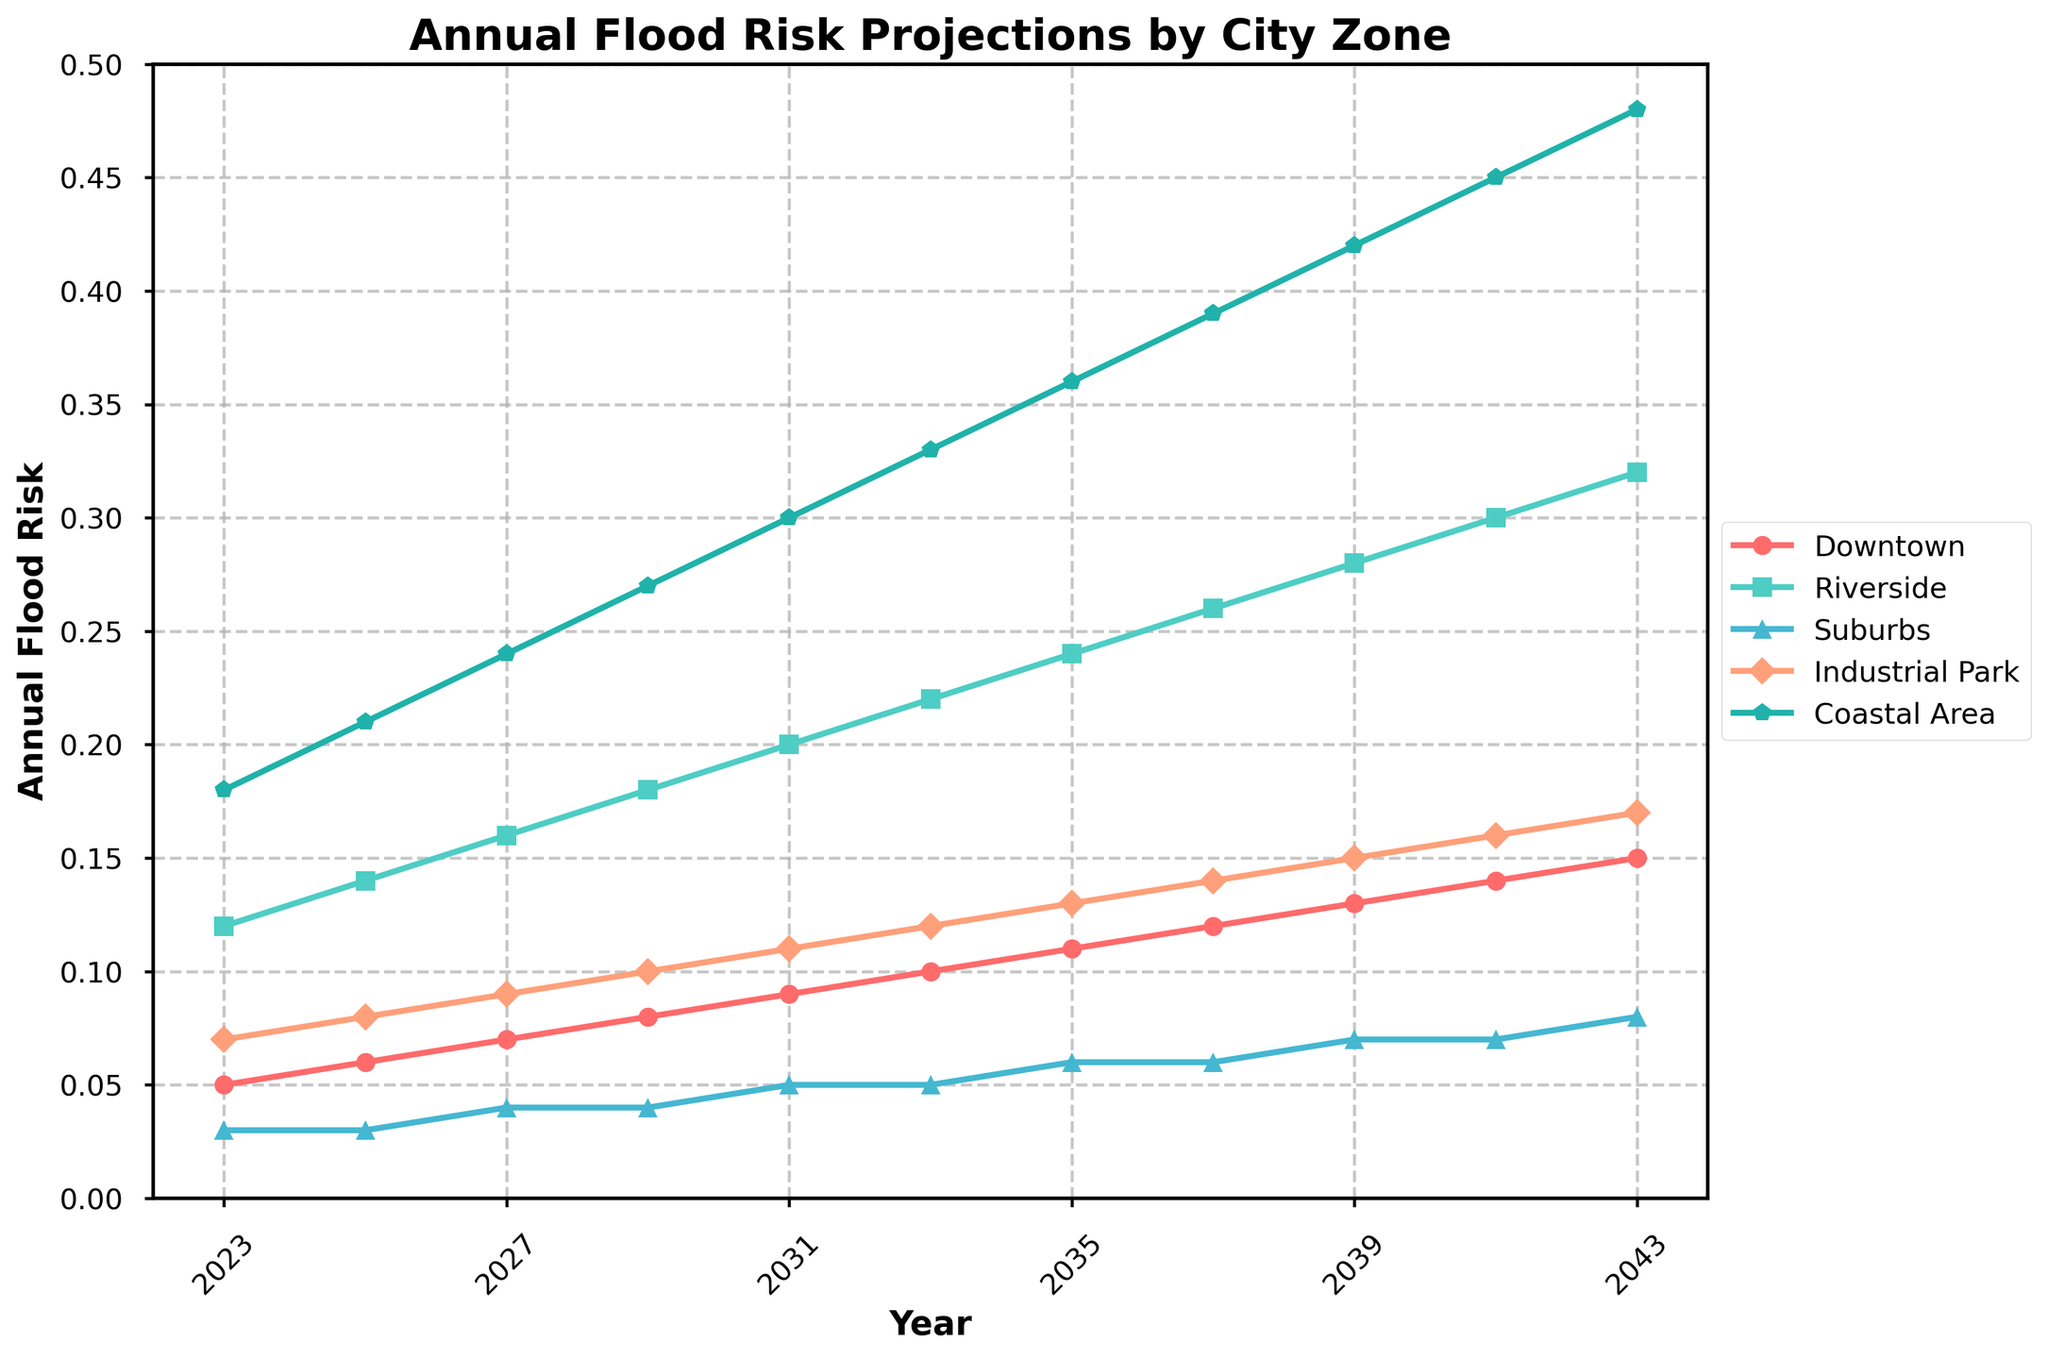What trend do you notice in the flood risk for the Coastal Area over the next 20 years? Observing the figure, the flood risk in the Coastal Area shows a steadily increasing trend from 0.18 in 2023 to 0.48 in 2043.
Answer: The flood risk in the Coastal Area increases steadily Which city zone shows the most significant increase in flood risk by 2043? By comparing all the city zones, the Coastal Area starts at 0.18 in 2023 and ends at 0.48 in 2043, showing the most significant increase of 0.30.
Answer: Coastal Area How does the flood risk in Riverside in 2027 compare to that in the Industrial Park in the same year? In 2027, the figure shows Riverside with a flood risk of 0.16, whereas Industrial Park has a risk of 0.09. Riverside's flood risk is higher.
Answer: Riverside has higher flood risk Between which years does the Downtown area see the highest rate of increase in flood risk? Observing the slope of the Downtown data line, the highest rate of increase appears between 2023 and 2025 (from 0.05 to 0.06) and 2039 to 2041 (from 0.13 to 0.14), both an increase of 0.01 but over different spans.
Answer: 2023-2025 and 2039-2041 What's the difference in flood risk between Downtown and Riverside in 2043? In 2043, Downtown has a flood risk of 0.15, while Riverside has a risk of 0.32. The difference is 0.32 - 0.15 = 0.17.
Answer: 0.17 Which city zones have a flood risk lower than 0.1 in 2037? Looking at 2037 on the figure, Downtown and Suburbs both have flood risks below 0.1, with values of 0.12 and 0.06 respectively.
Answer: Downtown and Suburbs By how much does the flood risk in the Industrial Park increase from 2023 to 2043? In 2023, the flood risk in the Industrial Park is 0.07, and in 2043, it is 0.17. The increase is 0.17 - 0.07 = 0.10.
Answer: 0.10 Compare the flood risk trends between the Suburbs and the Industrial Park. From the figure, both show increasing trends over the years, but the Suburbs start at 0.03 and end at 0.08 with a smaller slope compared to the Industrial Park, which starts at 0.07 and ends at 0.17. The Industrial Park has a steeper increase overall.
Answer: Industrial Park increases faster At what year does the flood risk in the Coastal Area first reach 0.30? According to the figure, the flood risk in the Coastal Area precisely reaches 0.30 in the year 2031.
Answer: 2031 